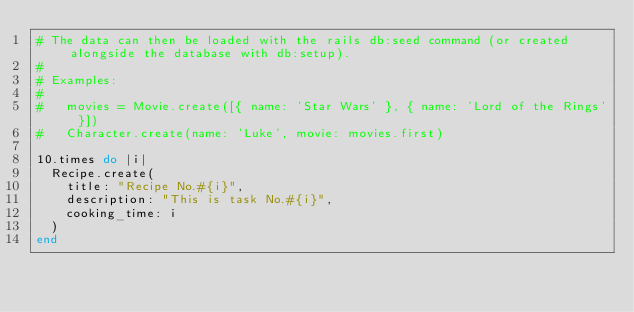Convert code to text. <code><loc_0><loc_0><loc_500><loc_500><_Ruby_># The data can then be loaded with the rails db:seed command (or created alongside the database with db:setup).
#
# Examples:
#
#   movies = Movie.create([{ name: 'Star Wars' }, { name: 'Lord of the Rings' }])
#   Character.create(name: 'Luke', movie: movies.first)

10.times do |i|
  Recipe.create(
    title: "Recipe No.#{i}",
    description: "This is task No.#{i}",
    cooking_time: i
  )
end
</code> 